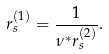<formula> <loc_0><loc_0><loc_500><loc_500>r _ { s } ^ { ( 1 ) } = \frac { 1 } { \nu ^ { \ast } r _ { s } ^ { ( 2 ) } } .</formula> 